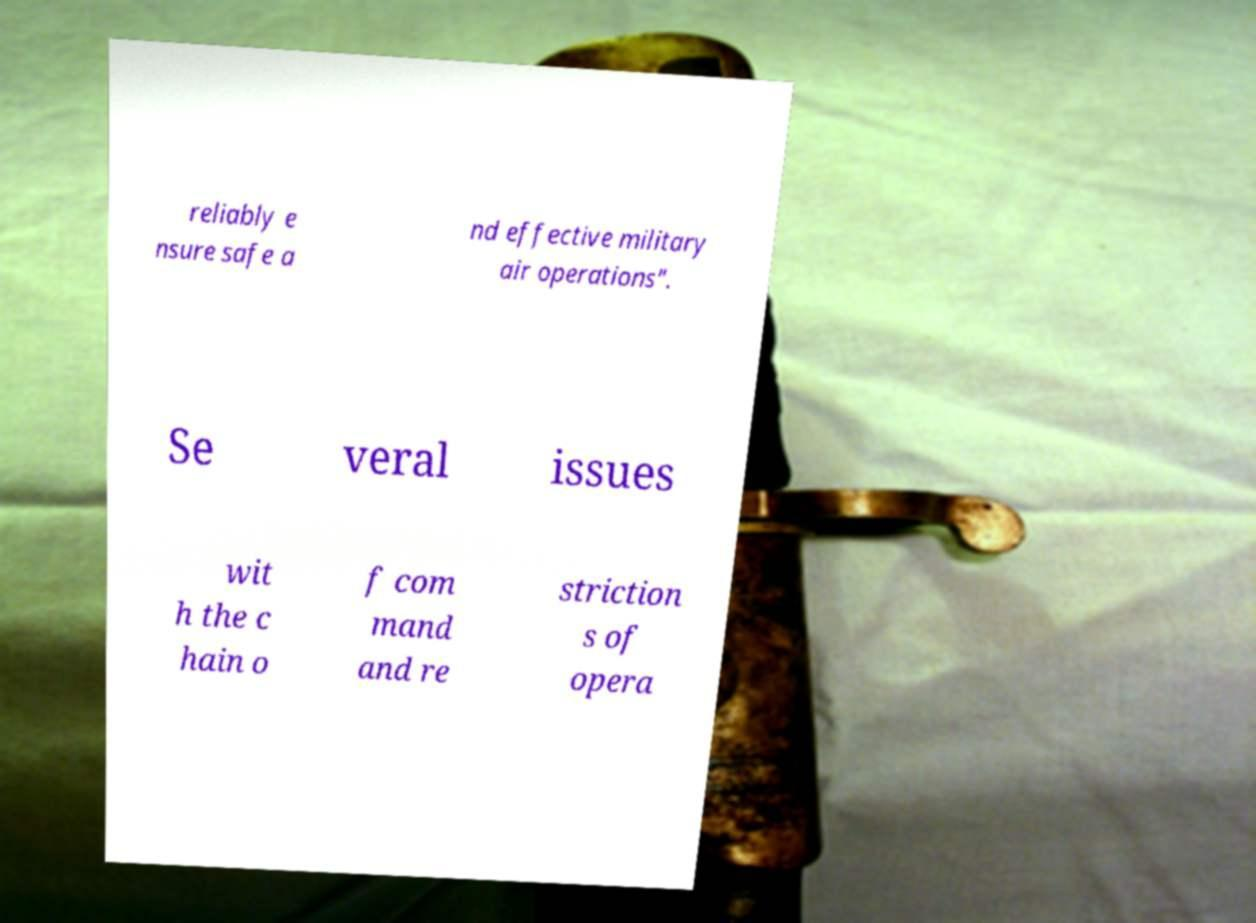Could you assist in decoding the text presented in this image and type it out clearly? reliably e nsure safe a nd effective military air operations". Se veral issues wit h the c hain o f com mand and re striction s of opera 